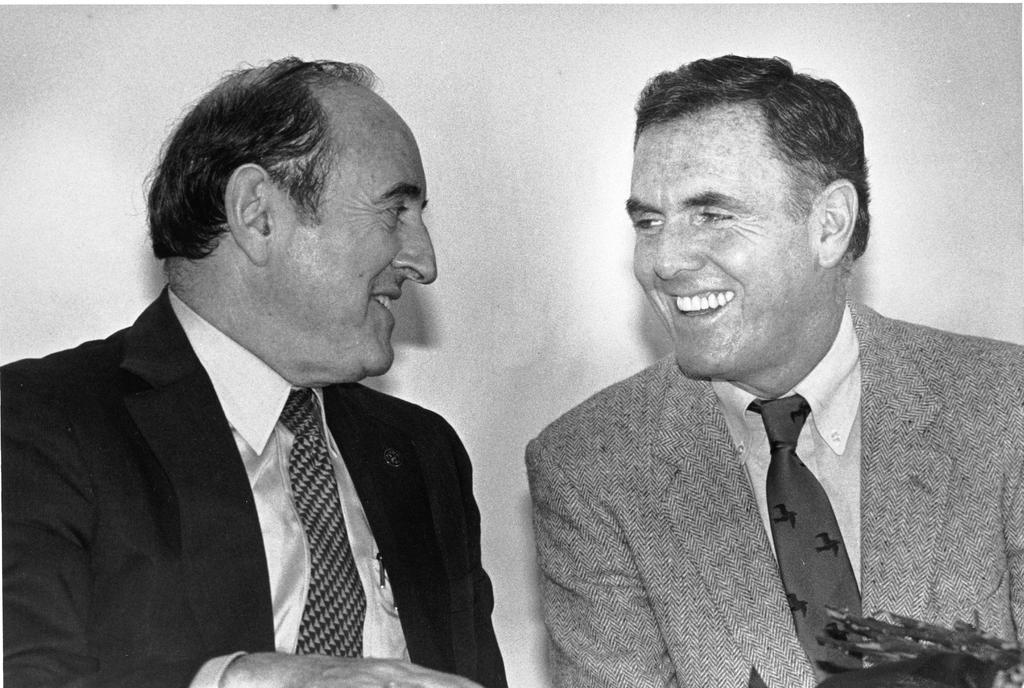How many people are in the image? There are two men in the image. What are the men wearing? Both men are wearing suits. What are the men doing in the image? The men are talking with each other. What can be seen in the background of the image? There is a wall in the background of the image. Can you tell me how deep the tub is in the image? There is no tub present in the image. What is the reason for the recess in the image? There is no recess present in the image. 